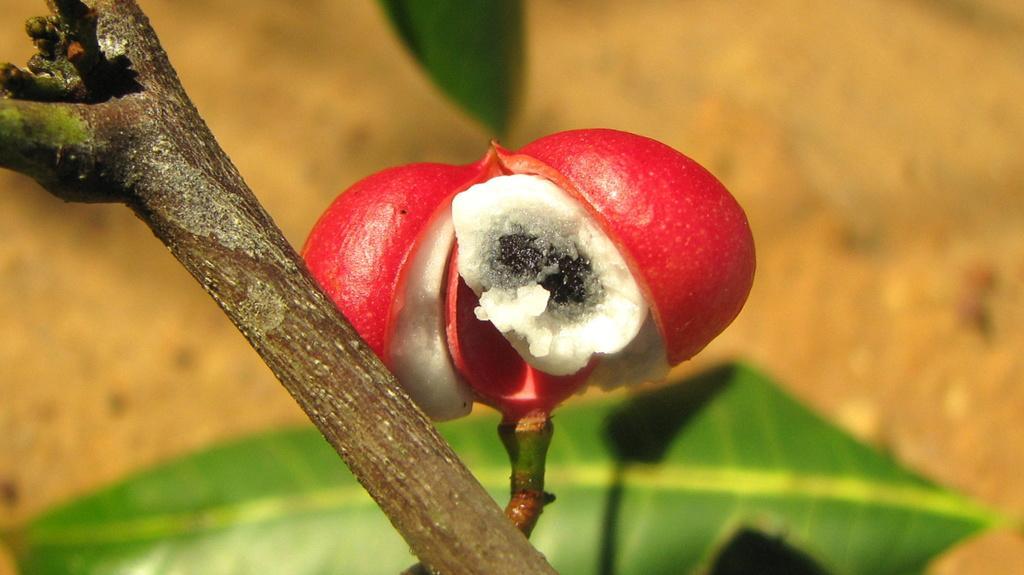Please provide a concise description of this image. In this picture we can see its look like a fruit. At the bottom of the image a leaf is present. 